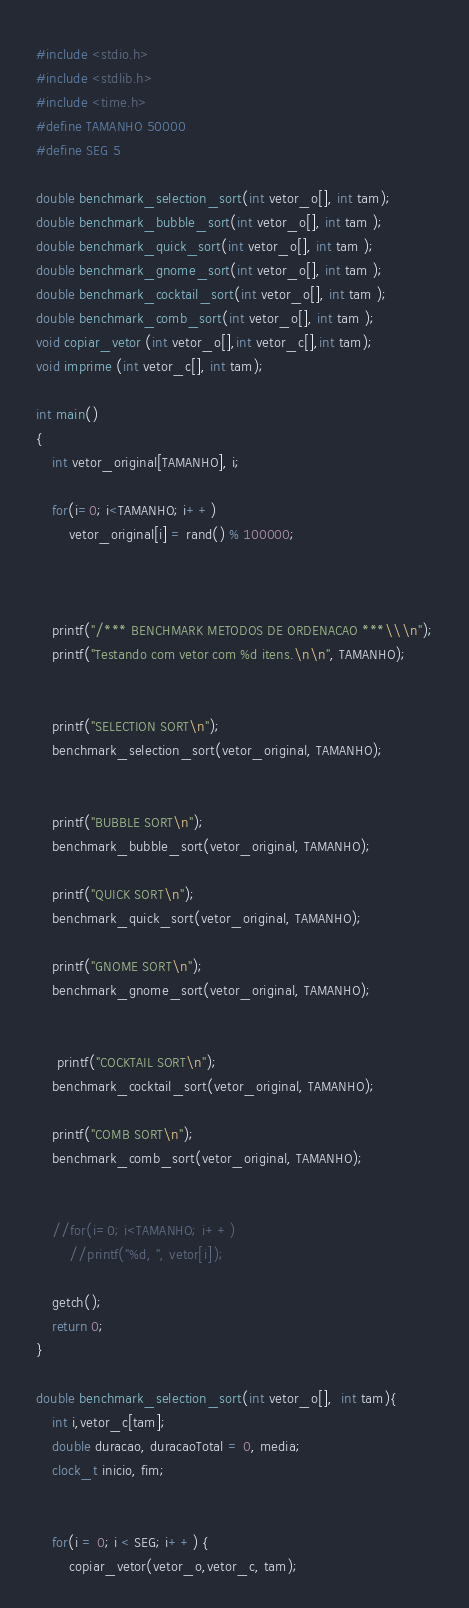Convert code to text. <code><loc_0><loc_0><loc_500><loc_500><_C_>#include <stdio.h>
#include <stdlib.h>
#include <time.h>
#define TAMANHO 50000
#define SEG 5

double benchmark_selection_sort(int vetor_o[], int tam);
double benchmark_bubble_sort(int vetor_o[], int tam );
double benchmark_quick_sort(int vetor_o[], int tam );
double benchmark_gnome_sort(int vetor_o[], int tam );
double benchmark_cocktail_sort(int vetor_o[], int tam );
double benchmark_comb_sort(int vetor_o[], int tam );
void copiar_vetor (int vetor_o[],int vetor_c[],int tam);
void imprime (int vetor_c[], int tam);

int main()
{
    int vetor_original[TAMANHO], i;

    for(i=0; i<TAMANHO; i++)
        vetor_original[i] = rand() % 100000;



    printf("/*** BENCHMARK METODOS DE ORDENACAO ***\\\n");
    printf("Testando com vetor com %d itens.\n\n", TAMANHO);


    printf("SELECTION SORT\n");
    benchmark_selection_sort(vetor_original, TAMANHO);


    printf("BUBBLE SORT\n");
    benchmark_bubble_sort(vetor_original, TAMANHO);

    printf("QUICK SORT\n");
    benchmark_quick_sort(vetor_original, TAMANHO);

    printf("GNOME SORT\n");
    benchmark_gnome_sort(vetor_original, TAMANHO);


     printf("COCKTAIL SORT\n");
    benchmark_cocktail_sort(vetor_original, TAMANHO);

    printf("COMB SORT\n");
    benchmark_comb_sort(vetor_original, TAMANHO);


    //for(i=0; i<TAMANHO; i++)
        //printf("%d, ", vetor[i]);

    getch();
    return 0;
}

double benchmark_selection_sort(int vetor_o[],  int tam){
    int i,vetor_c[tam];
    double duracao, duracaoTotal = 0, media;
    clock_t inicio, fim;


    for(i = 0; i < SEG; i++) {
        copiar_vetor(vetor_o,vetor_c, tam);</code> 